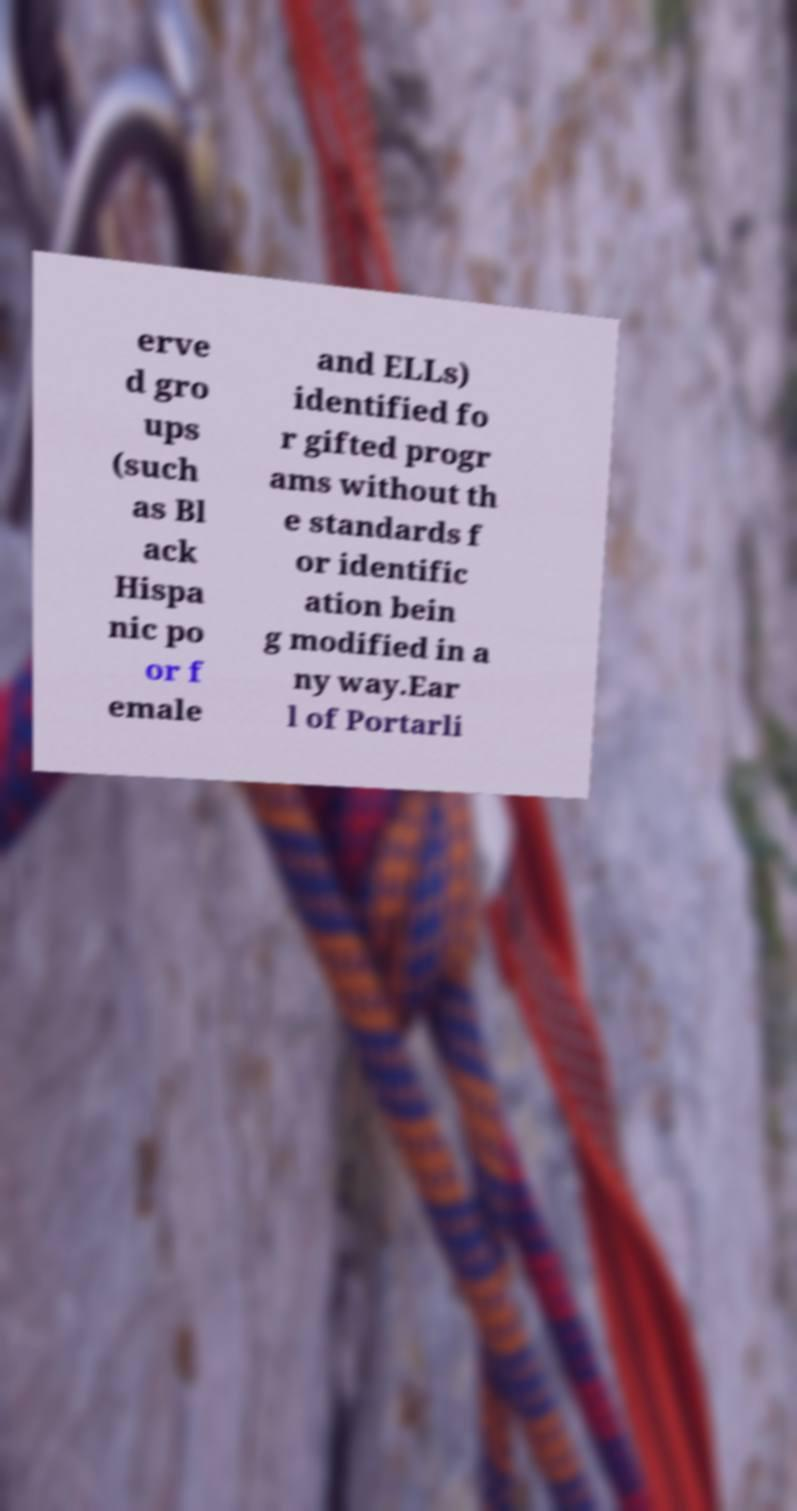Could you assist in decoding the text presented in this image and type it out clearly? erve d gro ups (such as Bl ack Hispa nic po or f emale and ELLs) identified fo r gifted progr ams without th e standards f or identific ation bein g modified in a ny way.Ear l of Portarli 